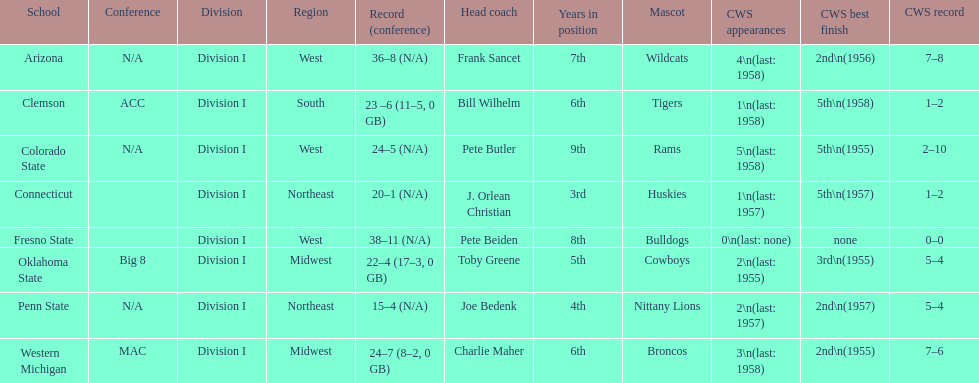Does clemson or western michigan have more cws appearances? Western Michigan. Would you mind parsing the complete table? {'header': ['School', 'Conference', 'Division', 'Region', 'Record (conference)', 'Head coach', 'Years in position', 'Mascot', 'CWS appearances', 'CWS best finish', 'CWS record'], 'rows': [['Arizona', 'N/A', 'Division I', 'West', '36–8 (N/A)', 'Frank Sancet', '7th', 'Wildcats', '4\\n(last: 1958)', '2nd\\n(1956)', '7–8'], ['Clemson', 'ACC', 'Division I', 'South', '23 –6 (11–5, 0 GB)', 'Bill Wilhelm', '6th', 'Tigers', '1\\n(last: 1958)', '5th\\n(1958)', '1–2'], ['Colorado State', 'N/A', 'Division I', 'West', '24–5 (N/A)', 'Pete Butler', '9th', 'Rams', '5\\n(last: 1958)', '5th\\n(1955)', '2–10'], ['Connecticut', '', 'Division I', 'Northeast', '20–1 (N/A)', 'J. Orlean Christian', '3rd', 'Huskies', '1\\n(last: 1957)', '5th\\n(1957)', '1–2'], ['Fresno State', '', 'Division I', 'West', '38–11 (N/A)', 'Pete Beiden', '8th', 'Bulldogs', '0\\n(last: none)', 'none', '0–0'], ['Oklahoma State', 'Big 8', 'Division I', 'Midwest', '22–4 (17–3, 0 GB)', 'Toby Greene', '5th', 'Cowboys', '2\\n(last: 1955)', '3rd\\n(1955)', '5–4'], ['Penn State', 'N/A', 'Division I', 'Northeast', '15–4 (N/A)', 'Joe Bedenk', '4th', 'Nittany Lions', '2\\n(last: 1957)', '2nd\\n(1957)', '5–4'], ['Western Michigan', 'MAC', 'Division I', 'Midwest', '24–7 (8–2, 0 GB)', 'Charlie Maher', '6th', 'Broncos', '3\\n(last: 1958)', '2nd\\n(1955)', '7–6']]} 